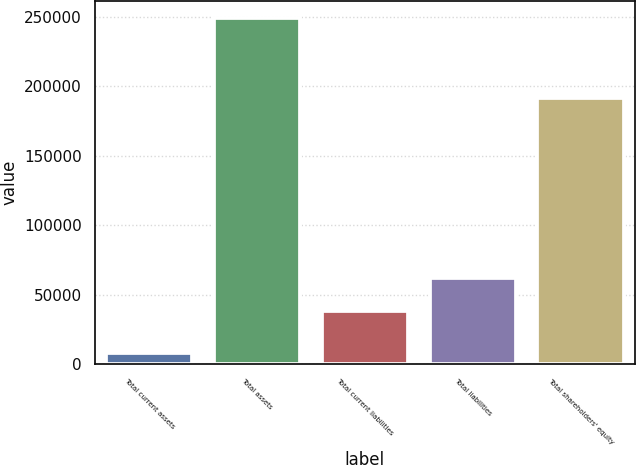Convert chart. <chart><loc_0><loc_0><loc_500><loc_500><bar_chart><fcel>Total current assets<fcel>Total assets<fcel>Total current liabilities<fcel>Total liabilities<fcel>Total shareholders' equity<nl><fcel>7833<fcel>249014<fcel>38266<fcel>62384.1<fcel>191508<nl></chart> 